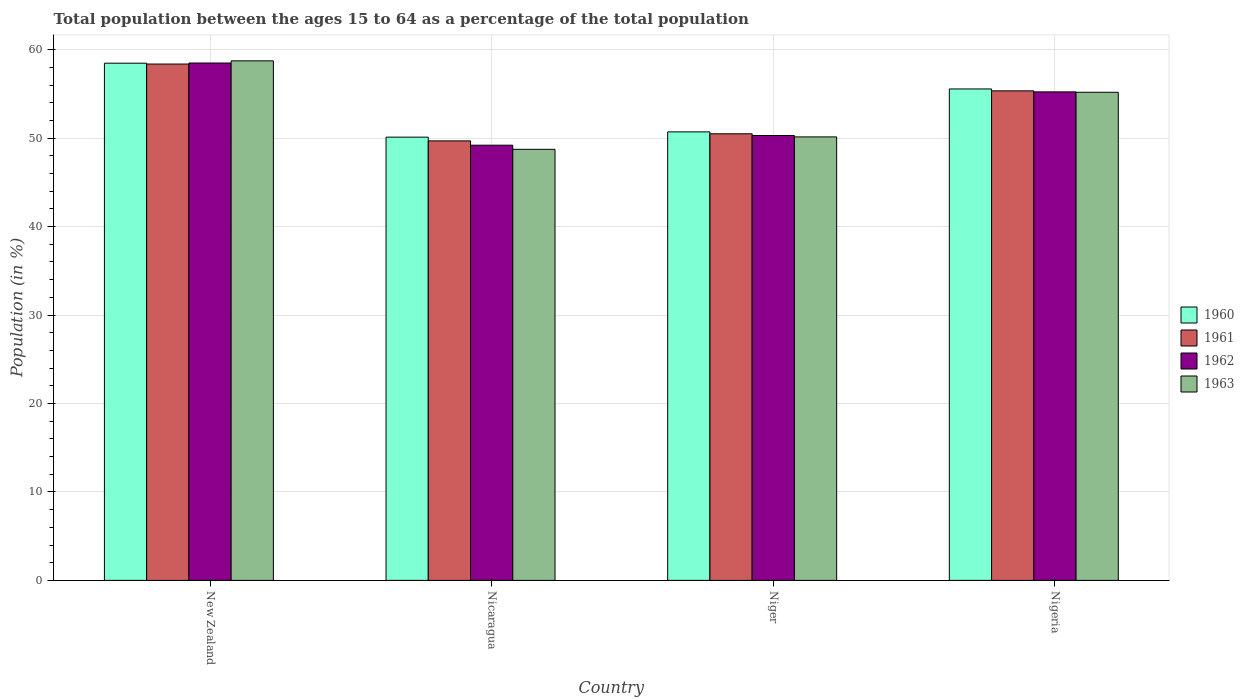How many groups of bars are there?
Ensure brevity in your answer.  4. What is the label of the 2nd group of bars from the left?
Make the answer very short. Nicaragua. In how many cases, is the number of bars for a given country not equal to the number of legend labels?
Your answer should be very brief. 0. What is the percentage of the population ages 15 to 64 in 1963 in Nicaragua?
Provide a short and direct response. 48.74. Across all countries, what is the maximum percentage of the population ages 15 to 64 in 1960?
Keep it short and to the point. 58.47. Across all countries, what is the minimum percentage of the population ages 15 to 64 in 1960?
Your response must be concise. 50.11. In which country was the percentage of the population ages 15 to 64 in 1962 maximum?
Offer a terse response. New Zealand. In which country was the percentage of the population ages 15 to 64 in 1963 minimum?
Keep it short and to the point. Nicaragua. What is the total percentage of the population ages 15 to 64 in 1962 in the graph?
Provide a succinct answer. 213.23. What is the difference between the percentage of the population ages 15 to 64 in 1963 in New Zealand and that in Niger?
Your answer should be compact. 8.6. What is the difference between the percentage of the population ages 15 to 64 in 1963 in Nigeria and the percentage of the population ages 15 to 64 in 1960 in Niger?
Provide a succinct answer. 4.48. What is the average percentage of the population ages 15 to 64 in 1963 per country?
Keep it short and to the point. 53.2. What is the difference between the percentage of the population ages 15 to 64 of/in 1962 and percentage of the population ages 15 to 64 of/in 1961 in Nigeria?
Keep it short and to the point. -0.11. In how many countries, is the percentage of the population ages 15 to 64 in 1961 greater than 6?
Ensure brevity in your answer.  4. What is the ratio of the percentage of the population ages 15 to 64 in 1961 in New Zealand to that in Nicaragua?
Offer a very short reply. 1.17. Is the percentage of the population ages 15 to 64 in 1963 in New Zealand less than that in Nigeria?
Your response must be concise. No. Is the difference between the percentage of the population ages 15 to 64 in 1962 in New Zealand and Nicaragua greater than the difference between the percentage of the population ages 15 to 64 in 1961 in New Zealand and Nicaragua?
Your response must be concise. Yes. What is the difference between the highest and the second highest percentage of the population ages 15 to 64 in 1961?
Ensure brevity in your answer.  7.88. What is the difference between the highest and the lowest percentage of the population ages 15 to 64 in 1962?
Your answer should be compact. 9.29. In how many countries, is the percentage of the population ages 15 to 64 in 1962 greater than the average percentage of the population ages 15 to 64 in 1962 taken over all countries?
Make the answer very short. 2. Is the sum of the percentage of the population ages 15 to 64 in 1963 in Nicaragua and Niger greater than the maximum percentage of the population ages 15 to 64 in 1960 across all countries?
Provide a short and direct response. Yes. Is it the case that in every country, the sum of the percentage of the population ages 15 to 64 in 1961 and percentage of the population ages 15 to 64 in 1962 is greater than the sum of percentage of the population ages 15 to 64 in 1960 and percentage of the population ages 15 to 64 in 1963?
Give a very brief answer. No. How many countries are there in the graph?
Your answer should be compact. 4. What is the difference between two consecutive major ticks on the Y-axis?
Give a very brief answer. 10. Are the values on the major ticks of Y-axis written in scientific E-notation?
Your answer should be very brief. No. Does the graph contain any zero values?
Make the answer very short. No. Does the graph contain grids?
Give a very brief answer. Yes. How many legend labels are there?
Your answer should be very brief. 4. What is the title of the graph?
Give a very brief answer. Total population between the ages 15 to 64 as a percentage of the total population. Does "1995" appear as one of the legend labels in the graph?
Your answer should be compact. No. What is the label or title of the X-axis?
Offer a terse response. Country. What is the label or title of the Y-axis?
Give a very brief answer. Population (in %). What is the Population (in %) in 1960 in New Zealand?
Make the answer very short. 58.47. What is the Population (in %) in 1961 in New Zealand?
Offer a very short reply. 58.38. What is the Population (in %) in 1962 in New Zealand?
Provide a succinct answer. 58.49. What is the Population (in %) in 1963 in New Zealand?
Give a very brief answer. 58.74. What is the Population (in %) of 1960 in Nicaragua?
Make the answer very short. 50.11. What is the Population (in %) of 1961 in Nicaragua?
Keep it short and to the point. 49.69. What is the Population (in %) in 1962 in Nicaragua?
Provide a short and direct response. 49.2. What is the Population (in %) in 1963 in Nicaragua?
Provide a short and direct response. 48.74. What is the Population (in %) in 1960 in Niger?
Your answer should be very brief. 50.71. What is the Population (in %) of 1961 in Niger?
Provide a succinct answer. 50.49. What is the Population (in %) of 1962 in Niger?
Provide a short and direct response. 50.3. What is the Population (in %) of 1963 in Niger?
Provide a succinct answer. 50.14. What is the Population (in %) of 1960 in Nigeria?
Your answer should be very brief. 55.56. What is the Population (in %) of 1961 in Nigeria?
Give a very brief answer. 55.35. What is the Population (in %) of 1962 in Nigeria?
Keep it short and to the point. 55.23. What is the Population (in %) in 1963 in Nigeria?
Make the answer very short. 55.19. Across all countries, what is the maximum Population (in %) of 1960?
Your answer should be very brief. 58.47. Across all countries, what is the maximum Population (in %) in 1961?
Give a very brief answer. 58.38. Across all countries, what is the maximum Population (in %) in 1962?
Keep it short and to the point. 58.49. Across all countries, what is the maximum Population (in %) of 1963?
Offer a very short reply. 58.74. Across all countries, what is the minimum Population (in %) in 1960?
Your response must be concise. 50.11. Across all countries, what is the minimum Population (in %) of 1961?
Make the answer very short. 49.69. Across all countries, what is the minimum Population (in %) in 1962?
Your answer should be compact. 49.2. Across all countries, what is the minimum Population (in %) in 1963?
Give a very brief answer. 48.74. What is the total Population (in %) of 1960 in the graph?
Your response must be concise. 214.86. What is the total Population (in %) of 1961 in the graph?
Offer a terse response. 213.91. What is the total Population (in %) of 1962 in the graph?
Keep it short and to the point. 213.23. What is the total Population (in %) of 1963 in the graph?
Give a very brief answer. 212.8. What is the difference between the Population (in %) of 1960 in New Zealand and that in Nicaragua?
Provide a short and direct response. 8.36. What is the difference between the Population (in %) in 1961 in New Zealand and that in Nicaragua?
Your answer should be compact. 8.69. What is the difference between the Population (in %) of 1962 in New Zealand and that in Nicaragua?
Your answer should be compact. 9.29. What is the difference between the Population (in %) in 1963 in New Zealand and that in Nicaragua?
Provide a short and direct response. 10. What is the difference between the Population (in %) in 1960 in New Zealand and that in Niger?
Give a very brief answer. 7.77. What is the difference between the Population (in %) in 1961 in New Zealand and that in Niger?
Give a very brief answer. 7.88. What is the difference between the Population (in %) of 1962 in New Zealand and that in Niger?
Offer a very short reply. 8.2. What is the difference between the Population (in %) of 1963 in New Zealand and that in Niger?
Your answer should be very brief. 8.6. What is the difference between the Population (in %) in 1960 in New Zealand and that in Nigeria?
Your response must be concise. 2.91. What is the difference between the Population (in %) in 1961 in New Zealand and that in Nigeria?
Provide a short and direct response. 3.03. What is the difference between the Population (in %) in 1962 in New Zealand and that in Nigeria?
Your response must be concise. 3.26. What is the difference between the Population (in %) of 1963 in New Zealand and that in Nigeria?
Provide a short and direct response. 3.55. What is the difference between the Population (in %) in 1960 in Nicaragua and that in Niger?
Keep it short and to the point. -0.6. What is the difference between the Population (in %) of 1961 in Nicaragua and that in Niger?
Offer a terse response. -0.8. What is the difference between the Population (in %) of 1962 in Nicaragua and that in Niger?
Give a very brief answer. -1.1. What is the difference between the Population (in %) in 1963 in Nicaragua and that in Niger?
Your response must be concise. -1.41. What is the difference between the Population (in %) of 1960 in Nicaragua and that in Nigeria?
Provide a succinct answer. -5.45. What is the difference between the Population (in %) in 1961 in Nicaragua and that in Nigeria?
Your response must be concise. -5.66. What is the difference between the Population (in %) in 1962 in Nicaragua and that in Nigeria?
Keep it short and to the point. -6.03. What is the difference between the Population (in %) in 1963 in Nicaragua and that in Nigeria?
Offer a very short reply. -6.45. What is the difference between the Population (in %) of 1960 in Niger and that in Nigeria?
Make the answer very short. -4.85. What is the difference between the Population (in %) of 1961 in Niger and that in Nigeria?
Provide a succinct answer. -4.85. What is the difference between the Population (in %) in 1962 in Niger and that in Nigeria?
Provide a succinct answer. -4.93. What is the difference between the Population (in %) of 1963 in Niger and that in Nigeria?
Provide a succinct answer. -5.05. What is the difference between the Population (in %) in 1960 in New Zealand and the Population (in %) in 1961 in Nicaragua?
Your answer should be very brief. 8.78. What is the difference between the Population (in %) in 1960 in New Zealand and the Population (in %) in 1962 in Nicaragua?
Keep it short and to the point. 9.27. What is the difference between the Population (in %) of 1960 in New Zealand and the Population (in %) of 1963 in Nicaragua?
Offer a very short reply. 9.74. What is the difference between the Population (in %) of 1961 in New Zealand and the Population (in %) of 1962 in Nicaragua?
Keep it short and to the point. 9.18. What is the difference between the Population (in %) in 1961 in New Zealand and the Population (in %) in 1963 in Nicaragua?
Give a very brief answer. 9.64. What is the difference between the Population (in %) in 1962 in New Zealand and the Population (in %) in 1963 in Nicaragua?
Provide a succinct answer. 9.76. What is the difference between the Population (in %) of 1960 in New Zealand and the Population (in %) of 1961 in Niger?
Ensure brevity in your answer.  7.98. What is the difference between the Population (in %) of 1960 in New Zealand and the Population (in %) of 1962 in Niger?
Your response must be concise. 8.18. What is the difference between the Population (in %) in 1960 in New Zealand and the Population (in %) in 1963 in Niger?
Make the answer very short. 8.33. What is the difference between the Population (in %) of 1961 in New Zealand and the Population (in %) of 1962 in Niger?
Your response must be concise. 8.08. What is the difference between the Population (in %) of 1961 in New Zealand and the Population (in %) of 1963 in Niger?
Provide a succinct answer. 8.24. What is the difference between the Population (in %) in 1962 in New Zealand and the Population (in %) in 1963 in Niger?
Make the answer very short. 8.35. What is the difference between the Population (in %) in 1960 in New Zealand and the Population (in %) in 1961 in Nigeria?
Your response must be concise. 3.13. What is the difference between the Population (in %) in 1960 in New Zealand and the Population (in %) in 1962 in Nigeria?
Keep it short and to the point. 3.24. What is the difference between the Population (in %) of 1960 in New Zealand and the Population (in %) of 1963 in Nigeria?
Make the answer very short. 3.29. What is the difference between the Population (in %) in 1961 in New Zealand and the Population (in %) in 1962 in Nigeria?
Offer a very short reply. 3.15. What is the difference between the Population (in %) of 1961 in New Zealand and the Population (in %) of 1963 in Nigeria?
Keep it short and to the point. 3.19. What is the difference between the Population (in %) in 1962 in New Zealand and the Population (in %) in 1963 in Nigeria?
Provide a succinct answer. 3.31. What is the difference between the Population (in %) in 1960 in Nicaragua and the Population (in %) in 1961 in Niger?
Your answer should be very brief. -0.38. What is the difference between the Population (in %) in 1960 in Nicaragua and the Population (in %) in 1962 in Niger?
Provide a succinct answer. -0.19. What is the difference between the Population (in %) in 1960 in Nicaragua and the Population (in %) in 1963 in Niger?
Your answer should be compact. -0.03. What is the difference between the Population (in %) in 1961 in Nicaragua and the Population (in %) in 1962 in Niger?
Provide a short and direct response. -0.61. What is the difference between the Population (in %) in 1961 in Nicaragua and the Population (in %) in 1963 in Niger?
Offer a very short reply. -0.45. What is the difference between the Population (in %) of 1962 in Nicaragua and the Population (in %) of 1963 in Niger?
Offer a terse response. -0.94. What is the difference between the Population (in %) of 1960 in Nicaragua and the Population (in %) of 1961 in Nigeria?
Provide a succinct answer. -5.23. What is the difference between the Population (in %) in 1960 in Nicaragua and the Population (in %) in 1962 in Nigeria?
Provide a short and direct response. -5.12. What is the difference between the Population (in %) in 1960 in Nicaragua and the Population (in %) in 1963 in Nigeria?
Provide a succinct answer. -5.07. What is the difference between the Population (in %) of 1961 in Nicaragua and the Population (in %) of 1962 in Nigeria?
Make the answer very short. -5.54. What is the difference between the Population (in %) of 1961 in Nicaragua and the Population (in %) of 1963 in Nigeria?
Ensure brevity in your answer.  -5.5. What is the difference between the Population (in %) of 1962 in Nicaragua and the Population (in %) of 1963 in Nigeria?
Offer a terse response. -5.98. What is the difference between the Population (in %) of 1960 in Niger and the Population (in %) of 1961 in Nigeria?
Give a very brief answer. -4.64. What is the difference between the Population (in %) of 1960 in Niger and the Population (in %) of 1962 in Nigeria?
Provide a short and direct response. -4.52. What is the difference between the Population (in %) in 1960 in Niger and the Population (in %) in 1963 in Nigeria?
Keep it short and to the point. -4.48. What is the difference between the Population (in %) in 1961 in Niger and the Population (in %) in 1962 in Nigeria?
Provide a succinct answer. -4.74. What is the difference between the Population (in %) in 1961 in Niger and the Population (in %) in 1963 in Nigeria?
Your answer should be compact. -4.69. What is the difference between the Population (in %) of 1962 in Niger and the Population (in %) of 1963 in Nigeria?
Your answer should be very brief. -4.89. What is the average Population (in %) of 1960 per country?
Make the answer very short. 53.71. What is the average Population (in %) of 1961 per country?
Make the answer very short. 53.48. What is the average Population (in %) in 1962 per country?
Your response must be concise. 53.31. What is the average Population (in %) in 1963 per country?
Provide a succinct answer. 53.2. What is the difference between the Population (in %) of 1960 and Population (in %) of 1961 in New Zealand?
Offer a terse response. 0.1. What is the difference between the Population (in %) in 1960 and Population (in %) in 1962 in New Zealand?
Offer a very short reply. -0.02. What is the difference between the Population (in %) of 1960 and Population (in %) of 1963 in New Zealand?
Give a very brief answer. -0.27. What is the difference between the Population (in %) in 1961 and Population (in %) in 1962 in New Zealand?
Provide a succinct answer. -0.12. What is the difference between the Population (in %) in 1961 and Population (in %) in 1963 in New Zealand?
Your response must be concise. -0.36. What is the difference between the Population (in %) in 1962 and Population (in %) in 1963 in New Zealand?
Your answer should be compact. -0.25. What is the difference between the Population (in %) in 1960 and Population (in %) in 1961 in Nicaragua?
Your answer should be very brief. 0.42. What is the difference between the Population (in %) of 1960 and Population (in %) of 1962 in Nicaragua?
Your answer should be very brief. 0.91. What is the difference between the Population (in %) in 1960 and Population (in %) in 1963 in Nicaragua?
Your answer should be compact. 1.38. What is the difference between the Population (in %) in 1961 and Population (in %) in 1962 in Nicaragua?
Provide a short and direct response. 0.49. What is the difference between the Population (in %) in 1961 and Population (in %) in 1963 in Nicaragua?
Ensure brevity in your answer.  0.96. What is the difference between the Population (in %) in 1962 and Population (in %) in 1963 in Nicaragua?
Provide a short and direct response. 0.47. What is the difference between the Population (in %) in 1960 and Population (in %) in 1961 in Niger?
Keep it short and to the point. 0.21. What is the difference between the Population (in %) in 1960 and Population (in %) in 1962 in Niger?
Ensure brevity in your answer.  0.41. What is the difference between the Population (in %) of 1960 and Population (in %) of 1963 in Niger?
Provide a succinct answer. 0.57. What is the difference between the Population (in %) of 1961 and Population (in %) of 1962 in Niger?
Your answer should be very brief. 0.2. What is the difference between the Population (in %) in 1961 and Population (in %) in 1963 in Niger?
Make the answer very short. 0.35. What is the difference between the Population (in %) of 1962 and Population (in %) of 1963 in Niger?
Your response must be concise. 0.16. What is the difference between the Population (in %) in 1960 and Population (in %) in 1961 in Nigeria?
Make the answer very short. 0.21. What is the difference between the Population (in %) in 1960 and Population (in %) in 1962 in Nigeria?
Provide a short and direct response. 0.33. What is the difference between the Population (in %) of 1960 and Population (in %) of 1963 in Nigeria?
Provide a succinct answer. 0.37. What is the difference between the Population (in %) in 1961 and Population (in %) in 1962 in Nigeria?
Offer a very short reply. 0.11. What is the difference between the Population (in %) of 1961 and Population (in %) of 1963 in Nigeria?
Offer a very short reply. 0.16. What is the difference between the Population (in %) in 1962 and Population (in %) in 1963 in Nigeria?
Your answer should be compact. 0.05. What is the ratio of the Population (in %) in 1960 in New Zealand to that in Nicaragua?
Offer a very short reply. 1.17. What is the ratio of the Population (in %) in 1961 in New Zealand to that in Nicaragua?
Provide a succinct answer. 1.17. What is the ratio of the Population (in %) of 1962 in New Zealand to that in Nicaragua?
Keep it short and to the point. 1.19. What is the ratio of the Population (in %) in 1963 in New Zealand to that in Nicaragua?
Keep it short and to the point. 1.21. What is the ratio of the Population (in %) of 1960 in New Zealand to that in Niger?
Provide a succinct answer. 1.15. What is the ratio of the Population (in %) in 1961 in New Zealand to that in Niger?
Keep it short and to the point. 1.16. What is the ratio of the Population (in %) in 1962 in New Zealand to that in Niger?
Provide a short and direct response. 1.16. What is the ratio of the Population (in %) of 1963 in New Zealand to that in Niger?
Provide a succinct answer. 1.17. What is the ratio of the Population (in %) of 1960 in New Zealand to that in Nigeria?
Provide a short and direct response. 1.05. What is the ratio of the Population (in %) in 1961 in New Zealand to that in Nigeria?
Make the answer very short. 1.05. What is the ratio of the Population (in %) in 1962 in New Zealand to that in Nigeria?
Keep it short and to the point. 1.06. What is the ratio of the Population (in %) in 1963 in New Zealand to that in Nigeria?
Provide a short and direct response. 1.06. What is the ratio of the Population (in %) of 1960 in Nicaragua to that in Niger?
Your response must be concise. 0.99. What is the ratio of the Population (in %) in 1961 in Nicaragua to that in Niger?
Provide a succinct answer. 0.98. What is the ratio of the Population (in %) of 1962 in Nicaragua to that in Niger?
Ensure brevity in your answer.  0.98. What is the ratio of the Population (in %) of 1963 in Nicaragua to that in Niger?
Offer a terse response. 0.97. What is the ratio of the Population (in %) of 1960 in Nicaragua to that in Nigeria?
Provide a succinct answer. 0.9. What is the ratio of the Population (in %) in 1961 in Nicaragua to that in Nigeria?
Offer a very short reply. 0.9. What is the ratio of the Population (in %) of 1962 in Nicaragua to that in Nigeria?
Provide a succinct answer. 0.89. What is the ratio of the Population (in %) in 1963 in Nicaragua to that in Nigeria?
Your answer should be compact. 0.88. What is the ratio of the Population (in %) of 1960 in Niger to that in Nigeria?
Make the answer very short. 0.91. What is the ratio of the Population (in %) in 1961 in Niger to that in Nigeria?
Your answer should be compact. 0.91. What is the ratio of the Population (in %) of 1962 in Niger to that in Nigeria?
Ensure brevity in your answer.  0.91. What is the ratio of the Population (in %) in 1963 in Niger to that in Nigeria?
Make the answer very short. 0.91. What is the difference between the highest and the second highest Population (in %) of 1960?
Keep it short and to the point. 2.91. What is the difference between the highest and the second highest Population (in %) in 1961?
Your answer should be compact. 3.03. What is the difference between the highest and the second highest Population (in %) of 1962?
Offer a very short reply. 3.26. What is the difference between the highest and the second highest Population (in %) of 1963?
Your answer should be very brief. 3.55. What is the difference between the highest and the lowest Population (in %) in 1960?
Offer a terse response. 8.36. What is the difference between the highest and the lowest Population (in %) in 1961?
Your answer should be compact. 8.69. What is the difference between the highest and the lowest Population (in %) of 1962?
Provide a short and direct response. 9.29. What is the difference between the highest and the lowest Population (in %) of 1963?
Ensure brevity in your answer.  10. 